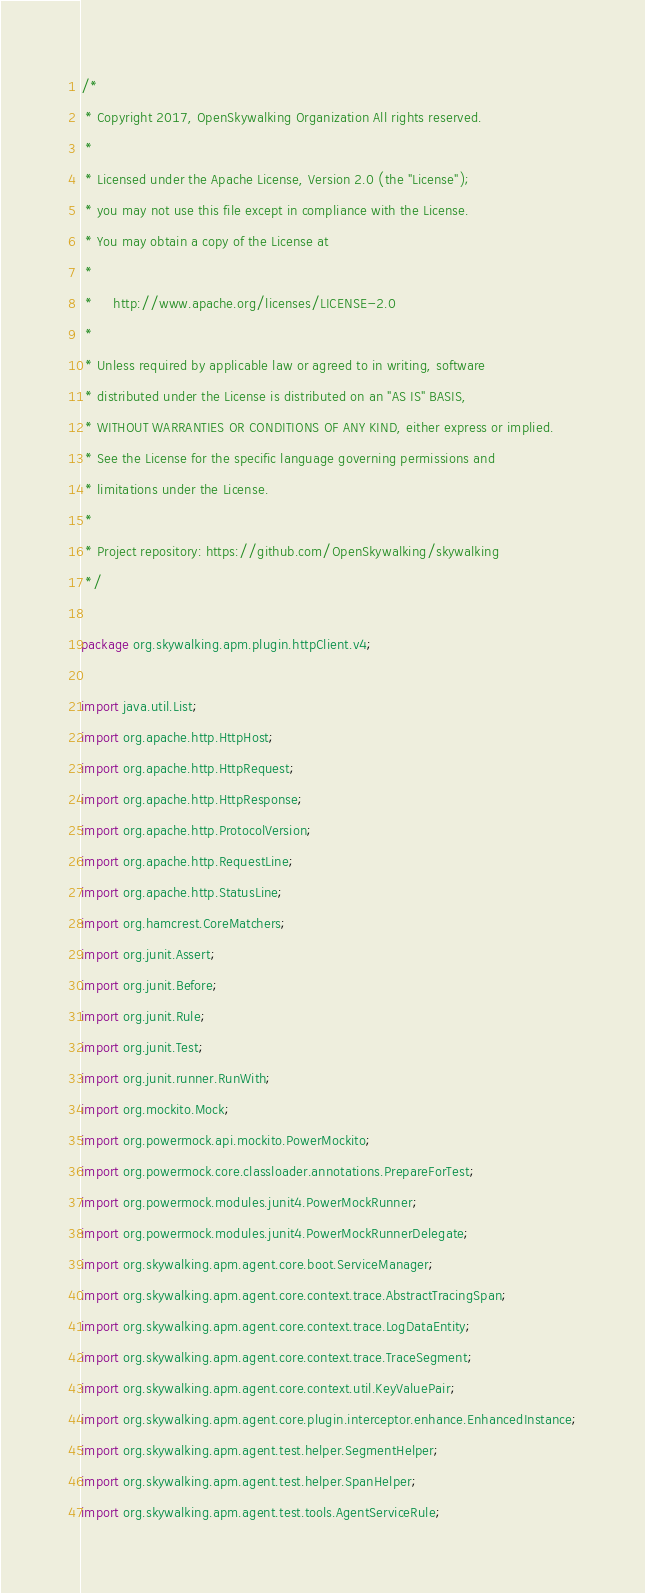<code> <loc_0><loc_0><loc_500><loc_500><_Java_>/*
 * Copyright 2017, OpenSkywalking Organization All rights reserved.
 *
 * Licensed under the Apache License, Version 2.0 (the "License");
 * you may not use this file except in compliance with the License.
 * You may obtain a copy of the License at
 *
 *     http://www.apache.org/licenses/LICENSE-2.0
 *
 * Unless required by applicable law or agreed to in writing, software
 * distributed under the License is distributed on an "AS IS" BASIS,
 * WITHOUT WARRANTIES OR CONDITIONS OF ANY KIND, either express or implied.
 * See the License for the specific language governing permissions and
 * limitations under the License.
 *
 * Project repository: https://github.com/OpenSkywalking/skywalking
 */

package org.skywalking.apm.plugin.httpClient.v4;

import java.util.List;
import org.apache.http.HttpHost;
import org.apache.http.HttpRequest;
import org.apache.http.HttpResponse;
import org.apache.http.ProtocolVersion;
import org.apache.http.RequestLine;
import org.apache.http.StatusLine;
import org.hamcrest.CoreMatchers;
import org.junit.Assert;
import org.junit.Before;
import org.junit.Rule;
import org.junit.Test;
import org.junit.runner.RunWith;
import org.mockito.Mock;
import org.powermock.api.mockito.PowerMockito;
import org.powermock.core.classloader.annotations.PrepareForTest;
import org.powermock.modules.junit4.PowerMockRunner;
import org.powermock.modules.junit4.PowerMockRunnerDelegate;
import org.skywalking.apm.agent.core.boot.ServiceManager;
import org.skywalking.apm.agent.core.context.trace.AbstractTracingSpan;
import org.skywalking.apm.agent.core.context.trace.LogDataEntity;
import org.skywalking.apm.agent.core.context.trace.TraceSegment;
import org.skywalking.apm.agent.core.context.util.KeyValuePair;
import org.skywalking.apm.agent.core.plugin.interceptor.enhance.EnhancedInstance;
import org.skywalking.apm.agent.test.helper.SegmentHelper;
import org.skywalking.apm.agent.test.helper.SpanHelper;
import org.skywalking.apm.agent.test.tools.AgentServiceRule;</code> 